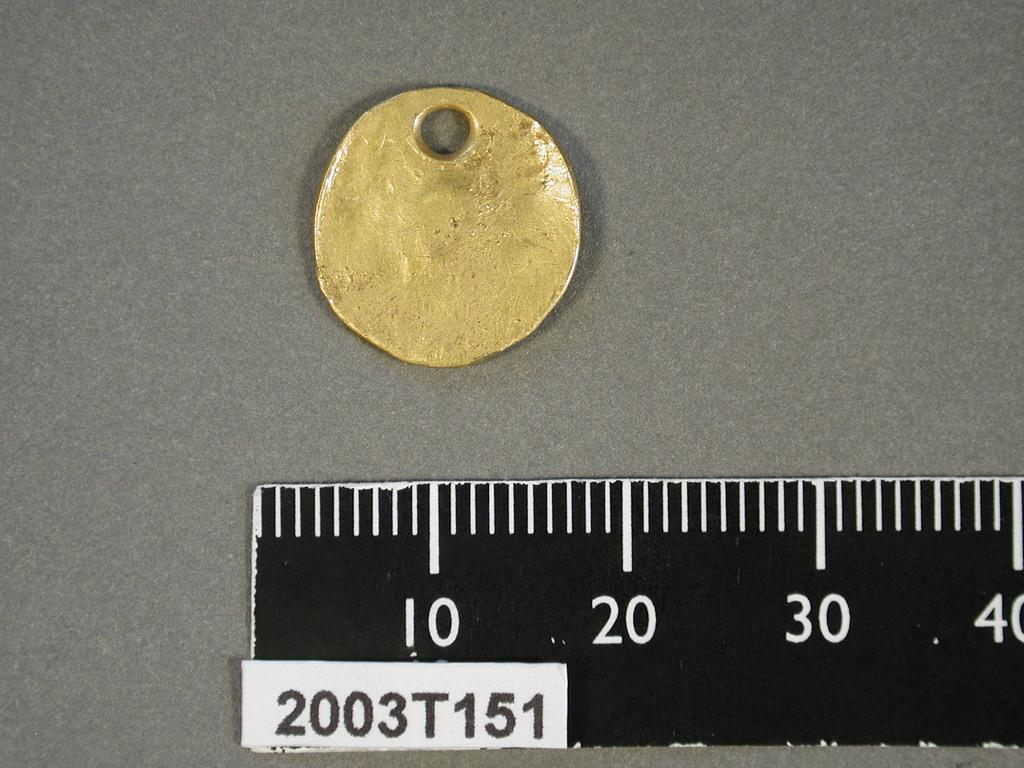<image>
Describe the image concisely. A gold colored metal item is above the 10 reading on the ruler. 